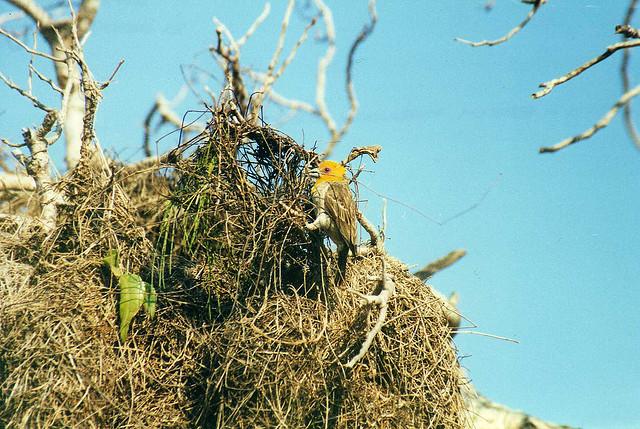Is the bird a peacock?
Give a very brief answer. No. What color is the bird?
Write a very short answer. Yellow. Has the bird destroyed the nest?
Answer briefly. No. 